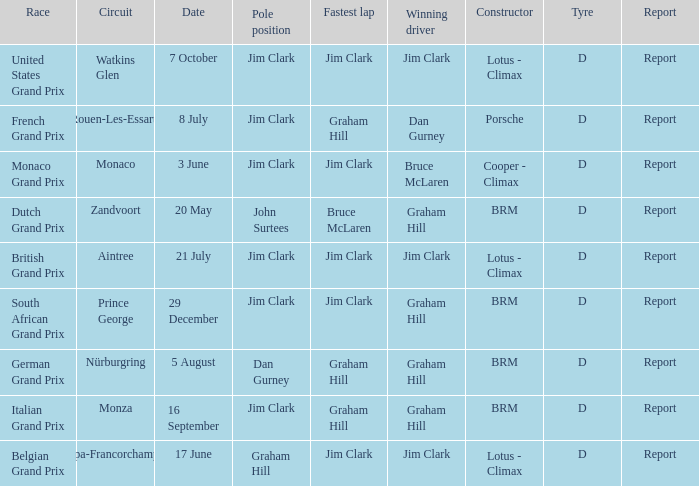What is the constructor at the United States Grand Prix? Lotus - Climax. 